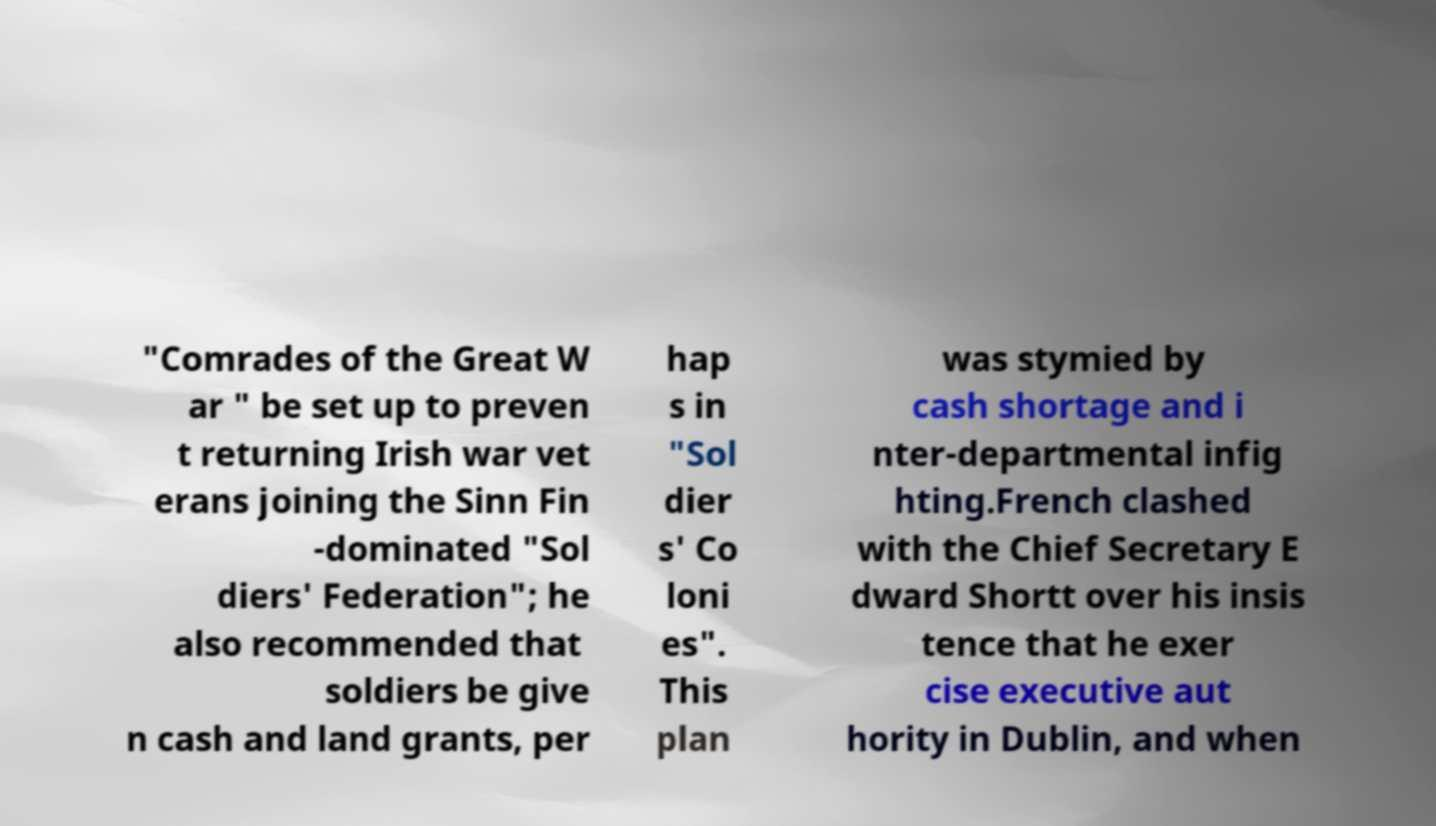What messages or text are displayed in this image? I need them in a readable, typed format. "Comrades of the Great W ar " be set up to preven t returning Irish war vet erans joining the Sinn Fin -dominated "Sol diers' Federation"; he also recommended that soldiers be give n cash and land grants, per hap s in "Sol dier s' Co loni es". This plan was stymied by cash shortage and i nter-departmental infig hting.French clashed with the Chief Secretary E dward Shortt over his insis tence that he exer cise executive aut hority in Dublin, and when 